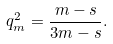Convert formula to latex. <formula><loc_0><loc_0><loc_500><loc_500>q _ { m } ^ { 2 } = \frac { m - s } { 3 m - s } .</formula> 